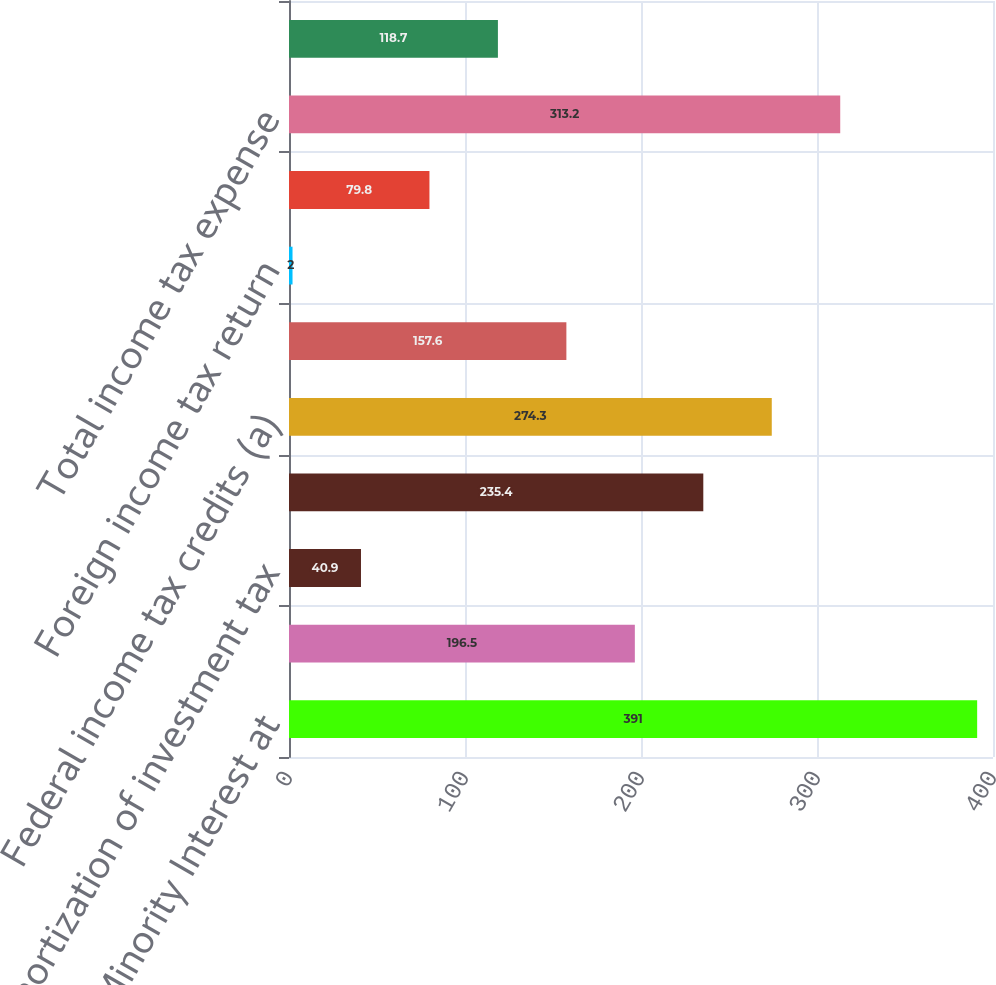<chart> <loc_0><loc_0><loc_500><loc_500><bar_chart><fcel>Taxes and Minority Interest at<fcel>State income taxes (a) (c) (d)<fcel>Amortization of investment tax<fcel>Difference related to income<fcel>Federal income tax credits (a)<fcel>Change in federal tax reserves<fcel>Foreign income tax return<fcel>Domestic manufacturing<fcel>Total income tax expense<fcel>Effective income tax rate<nl><fcel>391<fcel>196.5<fcel>40.9<fcel>235.4<fcel>274.3<fcel>157.6<fcel>2<fcel>79.8<fcel>313.2<fcel>118.7<nl></chart> 